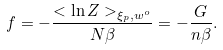Convert formula to latex. <formula><loc_0><loc_0><loc_500><loc_500>f = - \frac { < \ln Z > _ { \xi _ { p } , w ^ { o } } } { N \beta } = - \frac { G } { n \beta } .</formula> 